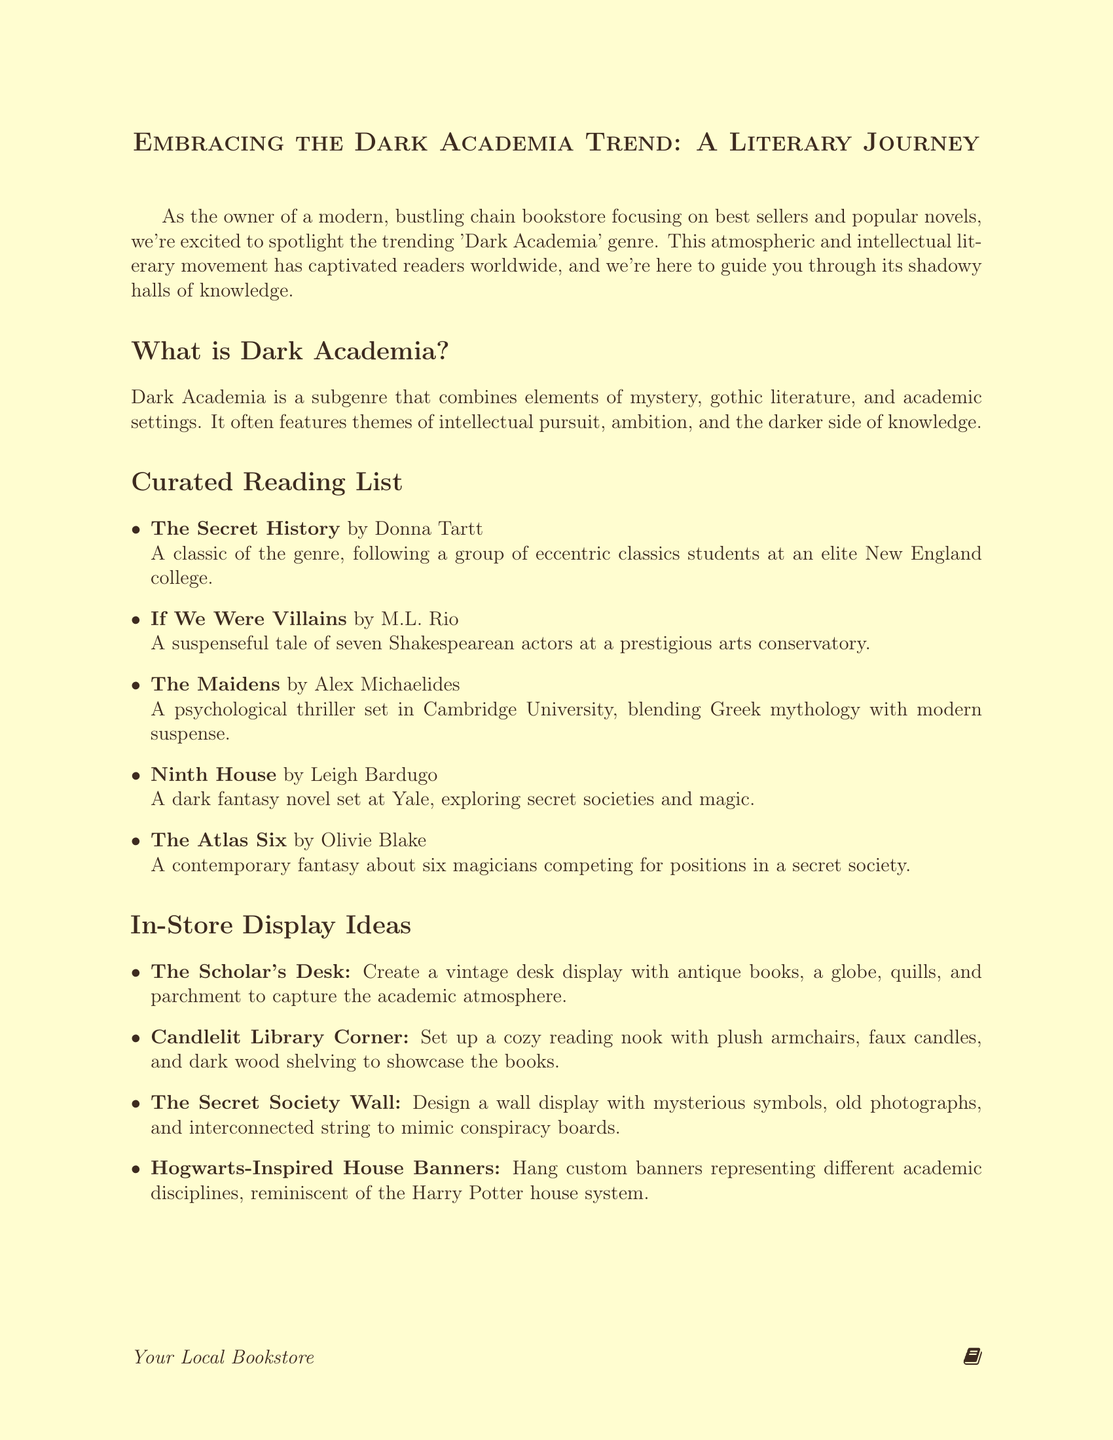What is the title of the newsletter? The title is mentioned at the beginning of the document as a key heading.
Answer: Embracing the Dark Academia Trend: A Literary Journey Who is the author of "The Secret History"? The author is specified in the curated reading list section.
Answer: Donna Tartt What type of display is called "Candlelit Library Corner"? This display type is one of four listed ideas for in-store promotion.
Answer: A cozy reading nook with plush armchairs, faux candles, and dark wood shelving How many books are in the curated reading list? The number of books is counted from the curated reading list section.
Answer: Five What is the hashtag used in the social media campaign? The hashtag is mentioned in the social media campaign section as a way to engage customers.
Answer: #DarkAcademiaReads What event type involves themed refreshments? The event type is specified in the promotional events section focusing on book clubs.
Answer: Dark Academia Book Club Which book features a psychological thriller set in Cambridge University? This information is derived from the curated reading list, detailing the plot of a specific book.
Answer: The Maidens How many promotional events are listed in total? The total is found by counting the promotional events listed in the document.
Answer: Four 